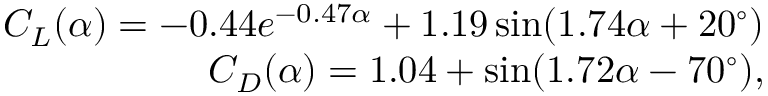<formula> <loc_0><loc_0><loc_500><loc_500>\begin{array} { r } { { C } _ { L } ( \alpha ) = - 0 . 4 4 e ^ { - 0 . 4 7 \alpha } + 1 . 1 9 \sin ( 1 . 7 4 \alpha + 2 0 ^ { \circ } ) } \\ { { C } _ { D } ( \alpha ) = 1 . 0 4 + \sin ( 1 . 7 2 \alpha - 7 0 ^ { \circ } ) , } \end{array}</formula> 